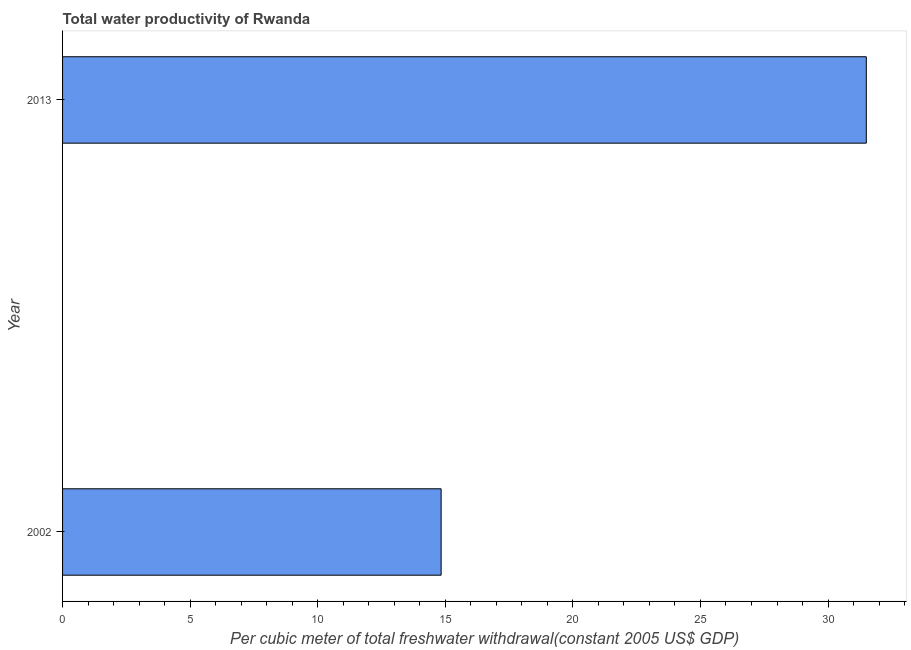Does the graph contain grids?
Your response must be concise. No. What is the title of the graph?
Provide a short and direct response. Total water productivity of Rwanda. What is the label or title of the X-axis?
Give a very brief answer. Per cubic meter of total freshwater withdrawal(constant 2005 US$ GDP). What is the label or title of the Y-axis?
Your answer should be very brief. Year. What is the total water productivity in 2013?
Provide a short and direct response. 31.5. Across all years, what is the maximum total water productivity?
Your answer should be very brief. 31.5. Across all years, what is the minimum total water productivity?
Your answer should be compact. 14.84. In which year was the total water productivity maximum?
Provide a succinct answer. 2013. What is the sum of the total water productivity?
Provide a succinct answer. 46.34. What is the difference between the total water productivity in 2002 and 2013?
Ensure brevity in your answer.  -16.66. What is the average total water productivity per year?
Keep it short and to the point. 23.17. What is the median total water productivity?
Keep it short and to the point. 23.17. What is the ratio of the total water productivity in 2002 to that in 2013?
Offer a very short reply. 0.47. Is the total water productivity in 2002 less than that in 2013?
Give a very brief answer. Yes. In how many years, is the total water productivity greater than the average total water productivity taken over all years?
Your response must be concise. 1. How many bars are there?
Keep it short and to the point. 2. What is the difference between two consecutive major ticks on the X-axis?
Provide a short and direct response. 5. Are the values on the major ticks of X-axis written in scientific E-notation?
Provide a succinct answer. No. What is the Per cubic meter of total freshwater withdrawal(constant 2005 US$ GDP) in 2002?
Ensure brevity in your answer.  14.84. What is the Per cubic meter of total freshwater withdrawal(constant 2005 US$ GDP) in 2013?
Give a very brief answer. 31.5. What is the difference between the Per cubic meter of total freshwater withdrawal(constant 2005 US$ GDP) in 2002 and 2013?
Give a very brief answer. -16.66. What is the ratio of the Per cubic meter of total freshwater withdrawal(constant 2005 US$ GDP) in 2002 to that in 2013?
Give a very brief answer. 0.47. 